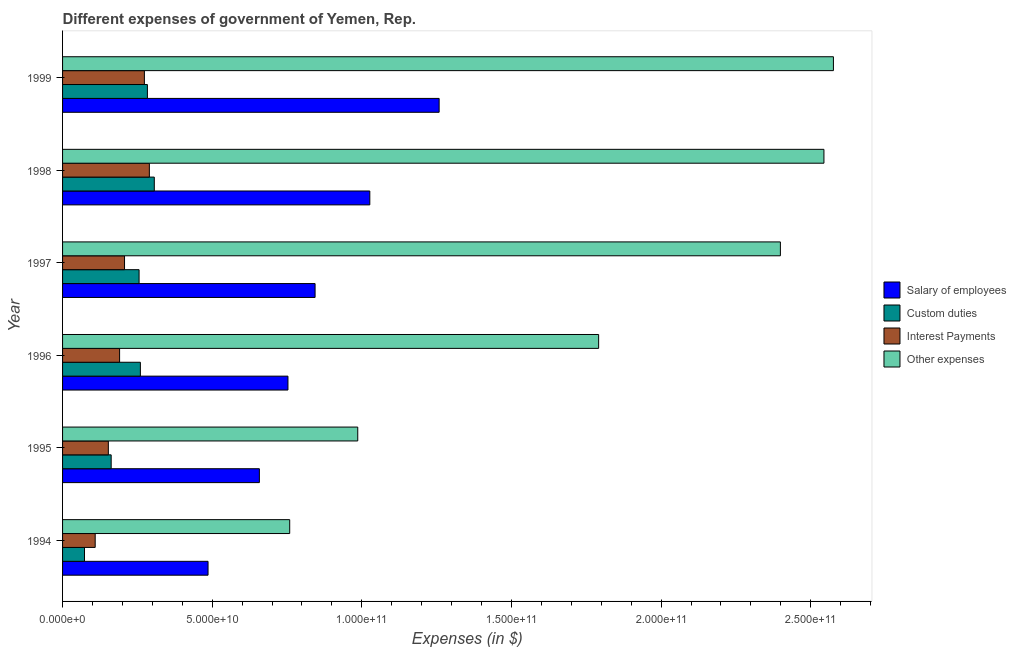How many different coloured bars are there?
Your answer should be compact. 4. How many bars are there on the 4th tick from the bottom?
Provide a succinct answer. 4. In how many cases, is the number of bars for a given year not equal to the number of legend labels?
Provide a succinct answer. 0. What is the amount spent on salary of employees in 1998?
Offer a terse response. 1.03e+11. Across all years, what is the maximum amount spent on custom duties?
Give a very brief answer. 3.07e+1. Across all years, what is the minimum amount spent on other expenses?
Provide a succinct answer. 7.59e+1. In which year was the amount spent on other expenses maximum?
Offer a very short reply. 1999. What is the total amount spent on interest payments in the graph?
Give a very brief answer. 1.22e+11. What is the difference between the amount spent on custom duties in 1995 and that in 1996?
Offer a very short reply. -9.76e+09. What is the difference between the amount spent on other expenses in 1997 and the amount spent on custom duties in 1996?
Provide a short and direct response. 2.14e+11. What is the average amount spent on other expenses per year?
Provide a succinct answer. 1.84e+11. In the year 1996, what is the difference between the amount spent on salary of employees and amount spent on other expenses?
Ensure brevity in your answer.  -1.04e+11. What is the ratio of the amount spent on other expenses in 1994 to that in 1999?
Make the answer very short. 0.29. Is the amount spent on interest payments in 1995 less than that in 1997?
Make the answer very short. Yes. Is the difference between the amount spent on salary of employees in 1996 and 1998 greater than the difference between the amount spent on interest payments in 1996 and 1998?
Offer a terse response. No. What is the difference between the highest and the second highest amount spent on custom duties?
Keep it short and to the point. 2.30e+09. What is the difference between the highest and the lowest amount spent on interest payments?
Keep it short and to the point. 1.81e+1. In how many years, is the amount spent on custom duties greater than the average amount spent on custom duties taken over all years?
Offer a terse response. 4. Is it the case that in every year, the sum of the amount spent on interest payments and amount spent on custom duties is greater than the sum of amount spent on other expenses and amount spent on salary of employees?
Ensure brevity in your answer.  No. What does the 4th bar from the top in 1999 represents?
Your answer should be compact. Salary of employees. What does the 2nd bar from the bottom in 1994 represents?
Offer a very short reply. Custom duties. Are all the bars in the graph horizontal?
Your answer should be very brief. Yes. How many years are there in the graph?
Keep it short and to the point. 6. Are the values on the major ticks of X-axis written in scientific E-notation?
Offer a very short reply. Yes. Does the graph contain any zero values?
Offer a terse response. No. Where does the legend appear in the graph?
Your answer should be compact. Center right. How many legend labels are there?
Provide a succinct answer. 4. What is the title of the graph?
Your answer should be compact. Different expenses of government of Yemen, Rep. Does "Debt policy" appear as one of the legend labels in the graph?
Your response must be concise. No. What is the label or title of the X-axis?
Provide a short and direct response. Expenses (in $). What is the label or title of the Y-axis?
Your response must be concise. Year. What is the Expenses (in $) of Salary of employees in 1994?
Your answer should be compact. 4.86e+1. What is the Expenses (in $) in Custom duties in 1994?
Ensure brevity in your answer.  7.33e+09. What is the Expenses (in $) in Interest Payments in 1994?
Keep it short and to the point. 1.09e+1. What is the Expenses (in $) of Other expenses in 1994?
Keep it short and to the point. 7.59e+1. What is the Expenses (in $) in Salary of employees in 1995?
Make the answer very short. 6.58e+1. What is the Expenses (in $) of Custom duties in 1995?
Give a very brief answer. 1.62e+1. What is the Expenses (in $) in Interest Payments in 1995?
Your response must be concise. 1.53e+1. What is the Expenses (in $) in Other expenses in 1995?
Ensure brevity in your answer.  9.86e+1. What is the Expenses (in $) in Salary of employees in 1996?
Provide a short and direct response. 7.53e+1. What is the Expenses (in $) of Custom duties in 1996?
Provide a short and direct response. 2.60e+1. What is the Expenses (in $) of Interest Payments in 1996?
Offer a very short reply. 1.91e+1. What is the Expenses (in $) of Other expenses in 1996?
Your answer should be very brief. 1.79e+11. What is the Expenses (in $) in Salary of employees in 1997?
Your answer should be very brief. 8.44e+1. What is the Expenses (in $) in Custom duties in 1997?
Ensure brevity in your answer.  2.56e+1. What is the Expenses (in $) of Interest Payments in 1997?
Your response must be concise. 2.07e+1. What is the Expenses (in $) of Other expenses in 1997?
Offer a terse response. 2.40e+11. What is the Expenses (in $) in Salary of employees in 1998?
Your answer should be compact. 1.03e+11. What is the Expenses (in $) of Custom duties in 1998?
Offer a very short reply. 3.07e+1. What is the Expenses (in $) in Interest Payments in 1998?
Provide a succinct answer. 2.90e+1. What is the Expenses (in $) of Other expenses in 1998?
Provide a short and direct response. 2.54e+11. What is the Expenses (in $) in Salary of employees in 1999?
Offer a very short reply. 1.26e+11. What is the Expenses (in $) in Custom duties in 1999?
Keep it short and to the point. 2.83e+1. What is the Expenses (in $) of Interest Payments in 1999?
Your answer should be compact. 2.73e+1. What is the Expenses (in $) in Other expenses in 1999?
Give a very brief answer. 2.58e+11. Across all years, what is the maximum Expenses (in $) in Salary of employees?
Provide a short and direct response. 1.26e+11. Across all years, what is the maximum Expenses (in $) of Custom duties?
Keep it short and to the point. 3.07e+1. Across all years, what is the maximum Expenses (in $) of Interest Payments?
Offer a terse response. 2.90e+1. Across all years, what is the maximum Expenses (in $) of Other expenses?
Make the answer very short. 2.58e+11. Across all years, what is the minimum Expenses (in $) of Salary of employees?
Keep it short and to the point. 4.86e+1. Across all years, what is the minimum Expenses (in $) of Custom duties?
Your answer should be very brief. 7.33e+09. Across all years, what is the minimum Expenses (in $) of Interest Payments?
Your answer should be compact. 1.09e+1. Across all years, what is the minimum Expenses (in $) of Other expenses?
Give a very brief answer. 7.59e+1. What is the total Expenses (in $) in Salary of employees in the graph?
Ensure brevity in your answer.  5.03e+11. What is the total Expenses (in $) in Custom duties in the graph?
Provide a short and direct response. 1.34e+11. What is the total Expenses (in $) in Interest Payments in the graph?
Offer a terse response. 1.22e+11. What is the total Expenses (in $) in Other expenses in the graph?
Your answer should be compact. 1.11e+12. What is the difference between the Expenses (in $) in Salary of employees in 1994 and that in 1995?
Keep it short and to the point. -1.72e+1. What is the difference between the Expenses (in $) in Custom duties in 1994 and that in 1995?
Make the answer very short. -8.91e+09. What is the difference between the Expenses (in $) in Interest Payments in 1994 and that in 1995?
Make the answer very short. -4.40e+09. What is the difference between the Expenses (in $) in Other expenses in 1994 and that in 1995?
Your answer should be very brief. -2.27e+1. What is the difference between the Expenses (in $) in Salary of employees in 1994 and that in 1996?
Provide a short and direct response. -2.67e+1. What is the difference between the Expenses (in $) in Custom duties in 1994 and that in 1996?
Keep it short and to the point. -1.87e+1. What is the difference between the Expenses (in $) in Interest Payments in 1994 and that in 1996?
Offer a very short reply. -8.15e+09. What is the difference between the Expenses (in $) of Other expenses in 1994 and that in 1996?
Offer a terse response. -1.03e+11. What is the difference between the Expenses (in $) of Salary of employees in 1994 and that in 1997?
Provide a short and direct response. -3.58e+1. What is the difference between the Expenses (in $) of Custom duties in 1994 and that in 1997?
Ensure brevity in your answer.  -1.82e+1. What is the difference between the Expenses (in $) of Interest Payments in 1994 and that in 1997?
Keep it short and to the point. -9.80e+09. What is the difference between the Expenses (in $) in Other expenses in 1994 and that in 1997?
Your answer should be very brief. -1.64e+11. What is the difference between the Expenses (in $) of Salary of employees in 1994 and that in 1998?
Offer a very short reply. -5.41e+1. What is the difference between the Expenses (in $) in Custom duties in 1994 and that in 1998?
Offer a very short reply. -2.33e+1. What is the difference between the Expenses (in $) of Interest Payments in 1994 and that in 1998?
Offer a terse response. -1.81e+1. What is the difference between the Expenses (in $) in Other expenses in 1994 and that in 1998?
Provide a succinct answer. -1.79e+11. What is the difference between the Expenses (in $) of Salary of employees in 1994 and that in 1999?
Your answer should be compact. -7.72e+1. What is the difference between the Expenses (in $) in Custom duties in 1994 and that in 1999?
Offer a very short reply. -2.10e+1. What is the difference between the Expenses (in $) in Interest Payments in 1994 and that in 1999?
Ensure brevity in your answer.  -1.64e+1. What is the difference between the Expenses (in $) of Other expenses in 1994 and that in 1999?
Your answer should be very brief. -1.82e+11. What is the difference between the Expenses (in $) in Salary of employees in 1995 and that in 1996?
Ensure brevity in your answer.  -9.55e+09. What is the difference between the Expenses (in $) in Custom duties in 1995 and that in 1996?
Provide a succinct answer. -9.76e+09. What is the difference between the Expenses (in $) in Interest Payments in 1995 and that in 1996?
Your answer should be very brief. -3.76e+09. What is the difference between the Expenses (in $) of Other expenses in 1995 and that in 1996?
Ensure brevity in your answer.  -8.05e+1. What is the difference between the Expenses (in $) in Salary of employees in 1995 and that in 1997?
Offer a very short reply. -1.86e+1. What is the difference between the Expenses (in $) in Custom duties in 1995 and that in 1997?
Provide a succinct answer. -9.32e+09. What is the difference between the Expenses (in $) in Interest Payments in 1995 and that in 1997?
Ensure brevity in your answer.  -5.41e+09. What is the difference between the Expenses (in $) of Other expenses in 1995 and that in 1997?
Provide a succinct answer. -1.41e+11. What is the difference between the Expenses (in $) in Salary of employees in 1995 and that in 1998?
Make the answer very short. -3.69e+1. What is the difference between the Expenses (in $) in Custom duties in 1995 and that in 1998?
Your response must be concise. -1.44e+1. What is the difference between the Expenses (in $) in Interest Payments in 1995 and that in 1998?
Provide a succinct answer. -1.37e+1. What is the difference between the Expenses (in $) of Other expenses in 1995 and that in 1998?
Your answer should be compact. -1.56e+11. What is the difference between the Expenses (in $) of Salary of employees in 1995 and that in 1999?
Your answer should be very brief. -6.01e+1. What is the difference between the Expenses (in $) in Custom duties in 1995 and that in 1999?
Keep it short and to the point. -1.21e+1. What is the difference between the Expenses (in $) of Interest Payments in 1995 and that in 1999?
Offer a very short reply. -1.20e+1. What is the difference between the Expenses (in $) of Other expenses in 1995 and that in 1999?
Provide a short and direct response. -1.59e+11. What is the difference between the Expenses (in $) of Salary of employees in 1996 and that in 1997?
Provide a short and direct response. -9.07e+09. What is the difference between the Expenses (in $) in Custom duties in 1996 and that in 1997?
Ensure brevity in your answer.  4.32e+08. What is the difference between the Expenses (in $) of Interest Payments in 1996 and that in 1997?
Give a very brief answer. -1.65e+09. What is the difference between the Expenses (in $) in Other expenses in 1996 and that in 1997?
Your response must be concise. -6.07e+1. What is the difference between the Expenses (in $) in Salary of employees in 1996 and that in 1998?
Your response must be concise. -2.74e+1. What is the difference between the Expenses (in $) in Custom duties in 1996 and that in 1998?
Make the answer very short. -4.66e+09. What is the difference between the Expenses (in $) in Interest Payments in 1996 and that in 1998?
Your response must be concise. -9.95e+09. What is the difference between the Expenses (in $) in Other expenses in 1996 and that in 1998?
Your answer should be compact. -7.53e+1. What is the difference between the Expenses (in $) of Salary of employees in 1996 and that in 1999?
Provide a short and direct response. -5.05e+1. What is the difference between the Expenses (in $) of Custom duties in 1996 and that in 1999?
Your answer should be very brief. -2.35e+09. What is the difference between the Expenses (in $) in Interest Payments in 1996 and that in 1999?
Your answer should be very brief. -8.29e+09. What is the difference between the Expenses (in $) of Other expenses in 1996 and that in 1999?
Give a very brief answer. -7.85e+1. What is the difference between the Expenses (in $) in Salary of employees in 1997 and that in 1998?
Your answer should be compact. -1.83e+1. What is the difference between the Expenses (in $) of Custom duties in 1997 and that in 1998?
Offer a terse response. -5.09e+09. What is the difference between the Expenses (in $) of Interest Payments in 1997 and that in 1998?
Keep it short and to the point. -8.29e+09. What is the difference between the Expenses (in $) of Other expenses in 1997 and that in 1998?
Your answer should be compact. -1.45e+1. What is the difference between the Expenses (in $) of Salary of employees in 1997 and that in 1999?
Your response must be concise. -4.15e+1. What is the difference between the Expenses (in $) of Custom duties in 1997 and that in 1999?
Keep it short and to the point. -2.78e+09. What is the difference between the Expenses (in $) in Interest Payments in 1997 and that in 1999?
Provide a succinct answer. -6.63e+09. What is the difference between the Expenses (in $) in Other expenses in 1997 and that in 1999?
Offer a very short reply. -1.77e+1. What is the difference between the Expenses (in $) of Salary of employees in 1998 and that in 1999?
Your answer should be very brief. -2.32e+1. What is the difference between the Expenses (in $) in Custom duties in 1998 and that in 1999?
Offer a terse response. 2.30e+09. What is the difference between the Expenses (in $) of Interest Payments in 1998 and that in 1999?
Keep it short and to the point. 1.66e+09. What is the difference between the Expenses (in $) in Other expenses in 1998 and that in 1999?
Ensure brevity in your answer.  -3.17e+09. What is the difference between the Expenses (in $) in Salary of employees in 1994 and the Expenses (in $) in Custom duties in 1995?
Provide a succinct answer. 3.24e+1. What is the difference between the Expenses (in $) in Salary of employees in 1994 and the Expenses (in $) in Interest Payments in 1995?
Offer a terse response. 3.33e+1. What is the difference between the Expenses (in $) in Salary of employees in 1994 and the Expenses (in $) in Other expenses in 1995?
Make the answer very short. -5.00e+1. What is the difference between the Expenses (in $) of Custom duties in 1994 and the Expenses (in $) of Interest Payments in 1995?
Offer a very short reply. -7.97e+09. What is the difference between the Expenses (in $) in Custom duties in 1994 and the Expenses (in $) in Other expenses in 1995?
Your answer should be very brief. -9.13e+1. What is the difference between the Expenses (in $) in Interest Payments in 1994 and the Expenses (in $) in Other expenses in 1995?
Provide a succinct answer. -8.77e+1. What is the difference between the Expenses (in $) in Salary of employees in 1994 and the Expenses (in $) in Custom duties in 1996?
Your response must be concise. 2.26e+1. What is the difference between the Expenses (in $) in Salary of employees in 1994 and the Expenses (in $) in Interest Payments in 1996?
Keep it short and to the point. 2.96e+1. What is the difference between the Expenses (in $) in Salary of employees in 1994 and the Expenses (in $) in Other expenses in 1996?
Provide a succinct answer. -1.31e+11. What is the difference between the Expenses (in $) in Custom duties in 1994 and the Expenses (in $) in Interest Payments in 1996?
Ensure brevity in your answer.  -1.17e+1. What is the difference between the Expenses (in $) of Custom duties in 1994 and the Expenses (in $) of Other expenses in 1996?
Your answer should be very brief. -1.72e+11. What is the difference between the Expenses (in $) in Interest Payments in 1994 and the Expenses (in $) in Other expenses in 1996?
Offer a very short reply. -1.68e+11. What is the difference between the Expenses (in $) of Salary of employees in 1994 and the Expenses (in $) of Custom duties in 1997?
Your answer should be compact. 2.30e+1. What is the difference between the Expenses (in $) in Salary of employees in 1994 and the Expenses (in $) in Interest Payments in 1997?
Keep it short and to the point. 2.79e+1. What is the difference between the Expenses (in $) in Salary of employees in 1994 and the Expenses (in $) in Other expenses in 1997?
Offer a very short reply. -1.91e+11. What is the difference between the Expenses (in $) of Custom duties in 1994 and the Expenses (in $) of Interest Payments in 1997?
Ensure brevity in your answer.  -1.34e+1. What is the difference between the Expenses (in $) in Custom duties in 1994 and the Expenses (in $) in Other expenses in 1997?
Provide a succinct answer. -2.33e+11. What is the difference between the Expenses (in $) of Interest Payments in 1994 and the Expenses (in $) of Other expenses in 1997?
Your response must be concise. -2.29e+11. What is the difference between the Expenses (in $) of Salary of employees in 1994 and the Expenses (in $) of Custom duties in 1998?
Your response must be concise. 1.80e+1. What is the difference between the Expenses (in $) of Salary of employees in 1994 and the Expenses (in $) of Interest Payments in 1998?
Offer a very short reply. 1.96e+1. What is the difference between the Expenses (in $) in Salary of employees in 1994 and the Expenses (in $) in Other expenses in 1998?
Provide a short and direct response. -2.06e+11. What is the difference between the Expenses (in $) of Custom duties in 1994 and the Expenses (in $) of Interest Payments in 1998?
Ensure brevity in your answer.  -2.17e+1. What is the difference between the Expenses (in $) in Custom duties in 1994 and the Expenses (in $) in Other expenses in 1998?
Provide a short and direct response. -2.47e+11. What is the difference between the Expenses (in $) in Interest Payments in 1994 and the Expenses (in $) in Other expenses in 1998?
Your response must be concise. -2.44e+11. What is the difference between the Expenses (in $) in Salary of employees in 1994 and the Expenses (in $) in Custom duties in 1999?
Your answer should be very brief. 2.03e+1. What is the difference between the Expenses (in $) of Salary of employees in 1994 and the Expenses (in $) of Interest Payments in 1999?
Offer a terse response. 2.13e+1. What is the difference between the Expenses (in $) in Salary of employees in 1994 and the Expenses (in $) in Other expenses in 1999?
Offer a very short reply. -2.09e+11. What is the difference between the Expenses (in $) of Custom duties in 1994 and the Expenses (in $) of Interest Payments in 1999?
Offer a terse response. -2.00e+1. What is the difference between the Expenses (in $) of Custom duties in 1994 and the Expenses (in $) of Other expenses in 1999?
Your answer should be very brief. -2.50e+11. What is the difference between the Expenses (in $) in Interest Payments in 1994 and the Expenses (in $) in Other expenses in 1999?
Offer a very short reply. -2.47e+11. What is the difference between the Expenses (in $) of Salary of employees in 1995 and the Expenses (in $) of Custom duties in 1996?
Make the answer very short. 3.98e+1. What is the difference between the Expenses (in $) of Salary of employees in 1995 and the Expenses (in $) of Interest Payments in 1996?
Provide a succinct answer. 4.67e+1. What is the difference between the Expenses (in $) of Salary of employees in 1995 and the Expenses (in $) of Other expenses in 1996?
Your response must be concise. -1.13e+11. What is the difference between the Expenses (in $) of Custom duties in 1995 and the Expenses (in $) of Interest Payments in 1996?
Ensure brevity in your answer.  -2.81e+09. What is the difference between the Expenses (in $) of Custom duties in 1995 and the Expenses (in $) of Other expenses in 1996?
Make the answer very short. -1.63e+11. What is the difference between the Expenses (in $) in Interest Payments in 1995 and the Expenses (in $) in Other expenses in 1996?
Keep it short and to the point. -1.64e+11. What is the difference between the Expenses (in $) in Salary of employees in 1995 and the Expenses (in $) in Custom duties in 1997?
Make the answer very short. 4.02e+1. What is the difference between the Expenses (in $) of Salary of employees in 1995 and the Expenses (in $) of Interest Payments in 1997?
Your answer should be compact. 4.51e+1. What is the difference between the Expenses (in $) of Salary of employees in 1995 and the Expenses (in $) of Other expenses in 1997?
Your answer should be very brief. -1.74e+11. What is the difference between the Expenses (in $) in Custom duties in 1995 and the Expenses (in $) in Interest Payments in 1997?
Make the answer very short. -4.47e+09. What is the difference between the Expenses (in $) in Custom duties in 1995 and the Expenses (in $) in Other expenses in 1997?
Offer a very short reply. -2.24e+11. What is the difference between the Expenses (in $) of Interest Payments in 1995 and the Expenses (in $) of Other expenses in 1997?
Make the answer very short. -2.25e+11. What is the difference between the Expenses (in $) in Salary of employees in 1995 and the Expenses (in $) in Custom duties in 1998?
Provide a short and direct response. 3.51e+1. What is the difference between the Expenses (in $) of Salary of employees in 1995 and the Expenses (in $) of Interest Payments in 1998?
Provide a succinct answer. 3.68e+1. What is the difference between the Expenses (in $) in Salary of employees in 1995 and the Expenses (in $) in Other expenses in 1998?
Give a very brief answer. -1.89e+11. What is the difference between the Expenses (in $) of Custom duties in 1995 and the Expenses (in $) of Interest Payments in 1998?
Your answer should be very brief. -1.28e+1. What is the difference between the Expenses (in $) of Custom duties in 1995 and the Expenses (in $) of Other expenses in 1998?
Offer a very short reply. -2.38e+11. What is the difference between the Expenses (in $) of Interest Payments in 1995 and the Expenses (in $) of Other expenses in 1998?
Keep it short and to the point. -2.39e+11. What is the difference between the Expenses (in $) of Salary of employees in 1995 and the Expenses (in $) of Custom duties in 1999?
Your answer should be very brief. 3.74e+1. What is the difference between the Expenses (in $) of Salary of employees in 1995 and the Expenses (in $) of Interest Payments in 1999?
Your answer should be compact. 3.84e+1. What is the difference between the Expenses (in $) of Salary of employees in 1995 and the Expenses (in $) of Other expenses in 1999?
Your response must be concise. -1.92e+11. What is the difference between the Expenses (in $) in Custom duties in 1995 and the Expenses (in $) in Interest Payments in 1999?
Offer a very short reply. -1.11e+1. What is the difference between the Expenses (in $) of Custom duties in 1995 and the Expenses (in $) of Other expenses in 1999?
Offer a terse response. -2.41e+11. What is the difference between the Expenses (in $) of Interest Payments in 1995 and the Expenses (in $) of Other expenses in 1999?
Ensure brevity in your answer.  -2.42e+11. What is the difference between the Expenses (in $) in Salary of employees in 1996 and the Expenses (in $) in Custom duties in 1997?
Your answer should be compact. 4.97e+1. What is the difference between the Expenses (in $) of Salary of employees in 1996 and the Expenses (in $) of Interest Payments in 1997?
Offer a very short reply. 5.46e+1. What is the difference between the Expenses (in $) of Salary of employees in 1996 and the Expenses (in $) of Other expenses in 1997?
Your answer should be very brief. -1.65e+11. What is the difference between the Expenses (in $) in Custom duties in 1996 and the Expenses (in $) in Interest Payments in 1997?
Provide a succinct answer. 5.29e+09. What is the difference between the Expenses (in $) in Custom duties in 1996 and the Expenses (in $) in Other expenses in 1997?
Your answer should be compact. -2.14e+11. What is the difference between the Expenses (in $) of Interest Payments in 1996 and the Expenses (in $) of Other expenses in 1997?
Your response must be concise. -2.21e+11. What is the difference between the Expenses (in $) of Salary of employees in 1996 and the Expenses (in $) of Custom duties in 1998?
Give a very brief answer. 4.47e+1. What is the difference between the Expenses (in $) of Salary of employees in 1996 and the Expenses (in $) of Interest Payments in 1998?
Offer a very short reply. 4.63e+1. What is the difference between the Expenses (in $) of Salary of employees in 1996 and the Expenses (in $) of Other expenses in 1998?
Provide a succinct answer. -1.79e+11. What is the difference between the Expenses (in $) of Custom duties in 1996 and the Expenses (in $) of Interest Payments in 1998?
Provide a short and direct response. -3.00e+09. What is the difference between the Expenses (in $) of Custom duties in 1996 and the Expenses (in $) of Other expenses in 1998?
Provide a succinct answer. -2.28e+11. What is the difference between the Expenses (in $) in Interest Payments in 1996 and the Expenses (in $) in Other expenses in 1998?
Make the answer very short. -2.35e+11. What is the difference between the Expenses (in $) in Salary of employees in 1996 and the Expenses (in $) in Custom duties in 1999?
Make the answer very short. 4.70e+1. What is the difference between the Expenses (in $) in Salary of employees in 1996 and the Expenses (in $) in Interest Payments in 1999?
Your response must be concise. 4.80e+1. What is the difference between the Expenses (in $) of Salary of employees in 1996 and the Expenses (in $) of Other expenses in 1999?
Offer a very short reply. -1.82e+11. What is the difference between the Expenses (in $) of Custom duties in 1996 and the Expenses (in $) of Interest Payments in 1999?
Your answer should be very brief. -1.34e+09. What is the difference between the Expenses (in $) of Custom duties in 1996 and the Expenses (in $) of Other expenses in 1999?
Keep it short and to the point. -2.32e+11. What is the difference between the Expenses (in $) of Interest Payments in 1996 and the Expenses (in $) of Other expenses in 1999?
Offer a terse response. -2.39e+11. What is the difference between the Expenses (in $) of Salary of employees in 1997 and the Expenses (in $) of Custom duties in 1998?
Provide a short and direct response. 5.37e+1. What is the difference between the Expenses (in $) of Salary of employees in 1997 and the Expenses (in $) of Interest Payments in 1998?
Your answer should be very brief. 5.54e+1. What is the difference between the Expenses (in $) of Salary of employees in 1997 and the Expenses (in $) of Other expenses in 1998?
Provide a succinct answer. -1.70e+11. What is the difference between the Expenses (in $) of Custom duties in 1997 and the Expenses (in $) of Interest Payments in 1998?
Provide a short and direct response. -3.44e+09. What is the difference between the Expenses (in $) of Custom duties in 1997 and the Expenses (in $) of Other expenses in 1998?
Ensure brevity in your answer.  -2.29e+11. What is the difference between the Expenses (in $) in Interest Payments in 1997 and the Expenses (in $) in Other expenses in 1998?
Make the answer very short. -2.34e+11. What is the difference between the Expenses (in $) of Salary of employees in 1997 and the Expenses (in $) of Custom duties in 1999?
Make the answer very short. 5.60e+1. What is the difference between the Expenses (in $) in Salary of employees in 1997 and the Expenses (in $) in Interest Payments in 1999?
Your answer should be very brief. 5.70e+1. What is the difference between the Expenses (in $) in Salary of employees in 1997 and the Expenses (in $) in Other expenses in 1999?
Provide a short and direct response. -1.73e+11. What is the difference between the Expenses (in $) of Custom duties in 1997 and the Expenses (in $) of Interest Payments in 1999?
Provide a succinct answer. -1.77e+09. What is the difference between the Expenses (in $) in Custom duties in 1997 and the Expenses (in $) in Other expenses in 1999?
Keep it short and to the point. -2.32e+11. What is the difference between the Expenses (in $) in Interest Payments in 1997 and the Expenses (in $) in Other expenses in 1999?
Your answer should be compact. -2.37e+11. What is the difference between the Expenses (in $) in Salary of employees in 1998 and the Expenses (in $) in Custom duties in 1999?
Your answer should be very brief. 7.43e+1. What is the difference between the Expenses (in $) of Salary of employees in 1998 and the Expenses (in $) of Interest Payments in 1999?
Your response must be concise. 7.53e+1. What is the difference between the Expenses (in $) of Salary of employees in 1998 and the Expenses (in $) of Other expenses in 1999?
Your answer should be very brief. -1.55e+11. What is the difference between the Expenses (in $) of Custom duties in 1998 and the Expenses (in $) of Interest Payments in 1999?
Make the answer very short. 3.31e+09. What is the difference between the Expenses (in $) in Custom duties in 1998 and the Expenses (in $) in Other expenses in 1999?
Keep it short and to the point. -2.27e+11. What is the difference between the Expenses (in $) in Interest Payments in 1998 and the Expenses (in $) in Other expenses in 1999?
Your response must be concise. -2.29e+11. What is the average Expenses (in $) in Salary of employees per year?
Give a very brief answer. 8.38e+1. What is the average Expenses (in $) of Custom duties per year?
Your answer should be compact. 2.24e+1. What is the average Expenses (in $) of Interest Payments per year?
Your response must be concise. 2.04e+1. What is the average Expenses (in $) of Other expenses per year?
Provide a succinct answer. 1.84e+11. In the year 1994, what is the difference between the Expenses (in $) in Salary of employees and Expenses (in $) in Custom duties?
Give a very brief answer. 4.13e+1. In the year 1994, what is the difference between the Expenses (in $) of Salary of employees and Expenses (in $) of Interest Payments?
Provide a short and direct response. 3.77e+1. In the year 1994, what is the difference between the Expenses (in $) in Salary of employees and Expenses (in $) in Other expenses?
Keep it short and to the point. -2.73e+1. In the year 1994, what is the difference between the Expenses (in $) in Custom duties and Expenses (in $) in Interest Payments?
Ensure brevity in your answer.  -3.57e+09. In the year 1994, what is the difference between the Expenses (in $) of Custom duties and Expenses (in $) of Other expenses?
Keep it short and to the point. -6.86e+1. In the year 1994, what is the difference between the Expenses (in $) of Interest Payments and Expenses (in $) of Other expenses?
Ensure brevity in your answer.  -6.50e+1. In the year 1995, what is the difference between the Expenses (in $) of Salary of employees and Expenses (in $) of Custom duties?
Give a very brief answer. 4.95e+1. In the year 1995, what is the difference between the Expenses (in $) in Salary of employees and Expenses (in $) in Interest Payments?
Your answer should be compact. 5.05e+1. In the year 1995, what is the difference between the Expenses (in $) in Salary of employees and Expenses (in $) in Other expenses?
Provide a succinct answer. -3.29e+1. In the year 1995, what is the difference between the Expenses (in $) of Custom duties and Expenses (in $) of Interest Payments?
Your response must be concise. 9.43e+08. In the year 1995, what is the difference between the Expenses (in $) of Custom duties and Expenses (in $) of Other expenses?
Your answer should be compact. -8.24e+1. In the year 1995, what is the difference between the Expenses (in $) of Interest Payments and Expenses (in $) of Other expenses?
Ensure brevity in your answer.  -8.33e+1. In the year 1996, what is the difference between the Expenses (in $) in Salary of employees and Expenses (in $) in Custom duties?
Offer a very short reply. 4.93e+1. In the year 1996, what is the difference between the Expenses (in $) in Salary of employees and Expenses (in $) in Interest Payments?
Ensure brevity in your answer.  5.63e+1. In the year 1996, what is the difference between the Expenses (in $) in Salary of employees and Expenses (in $) in Other expenses?
Offer a terse response. -1.04e+11. In the year 1996, what is the difference between the Expenses (in $) in Custom duties and Expenses (in $) in Interest Payments?
Provide a short and direct response. 6.94e+09. In the year 1996, what is the difference between the Expenses (in $) in Custom duties and Expenses (in $) in Other expenses?
Your answer should be compact. -1.53e+11. In the year 1996, what is the difference between the Expenses (in $) in Interest Payments and Expenses (in $) in Other expenses?
Offer a terse response. -1.60e+11. In the year 1997, what is the difference between the Expenses (in $) of Salary of employees and Expenses (in $) of Custom duties?
Provide a succinct answer. 5.88e+1. In the year 1997, what is the difference between the Expenses (in $) of Salary of employees and Expenses (in $) of Interest Payments?
Your answer should be very brief. 6.37e+1. In the year 1997, what is the difference between the Expenses (in $) in Salary of employees and Expenses (in $) in Other expenses?
Offer a terse response. -1.55e+11. In the year 1997, what is the difference between the Expenses (in $) in Custom duties and Expenses (in $) in Interest Payments?
Make the answer very short. 4.86e+09. In the year 1997, what is the difference between the Expenses (in $) in Custom duties and Expenses (in $) in Other expenses?
Your answer should be compact. -2.14e+11. In the year 1997, what is the difference between the Expenses (in $) in Interest Payments and Expenses (in $) in Other expenses?
Make the answer very short. -2.19e+11. In the year 1998, what is the difference between the Expenses (in $) in Salary of employees and Expenses (in $) in Custom duties?
Offer a very short reply. 7.20e+1. In the year 1998, what is the difference between the Expenses (in $) in Salary of employees and Expenses (in $) in Interest Payments?
Your answer should be very brief. 7.37e+1. In the year 1998, what is the difference between the Expenses (in $) of Salary of employees and Expenses (in $) of Other expenses?
Your answer should be compact. -1.52e+11. In the year 1998, what is the difference between the Expenses (in $) in Custom duties and Expenses (in $) in Interest Payments?
Ensure brevity in your answer.  1.65e+09. In the year 1998, what is the difference between the Expenses (in $) of Custom duties and Expenses (in $) of Other expenses?
Make the answer very short. -2.24e+11. In the year 1998, what is the difference between the Expenses (in $) of Interest Payments and Expenses (in $) of Other expenses?
Your answer should be very brief. -2.25e+11. In the year 1999, what is the difference between the Expenses (in $) of Salary of employees and Expenses (in $) of Custom duties?
Offer a terse response. 9.75e+1. In the year 1999, what is the difference between the Expenses (in $) in Salary of employees and Expenses (in $) in Interest Payments?
Your response must be concise. 9.85e+1. In the year 1999, what is the difference between the Expenses (in $) in Salary of employees and Expenses (in $) in Other expenses?
Your response must be concise. -1.32e+11. In the year 1999, what is the difference between the Expenses (in $) in Custom duties and Expenses (in $) in Interest Payments?
Make the answer very short. 1.01e+09. In the year 1999, what is the difference between the Expenses (in $) in Custom duties and Expenses (in $) in Other expenses?
Your answer should be compact. -2.29e+11. In the year 1999, what is the difference between the Expenses (in $) in Interest Payments and Expenses (in $) in Other expenses?
Offer a very short reply. -2.30e+11. What is the ratio of the Expenses (in $) of Salary of employees in 1994 to that in 1995?
Offer a very short reply. 0.74. What is the ratio of the Expenses (in $) in Custom duties in 1994 to that in 1995?
Provide a succinct answer. 0.45. What is the ratio of the Expenses (in $) of Interest Payments in 1994 to that in 1995?
Ensure brevity in your answer.  0.71. What is the ratio of the Expenses (in $) of Other expenses in 1994 to that in 1995?
Your answer should be compact. 0.77. What is the ratio of the Expenses (in $) of Salary of employees in 1994 to that in 1996?
Provide a succinct answer. 0.65. What is the ratio of the Expenses (in $) of Custom duties in 1994 to that in 1996?
Provide a short and direct response. 0.28. What is the ratio of the Expenses (in $) in Interest Payments in 1994 to that in 1996?
Offer a terse response. 0.57. What is the ratio of the Expenses (in $) of Other expenses in 1994 to that in 1996?
Keep it short and to the point. 0.42. What is the ratio of the Expenses (in $) of Salary of employees in 1994 to that in 1997?
Give a very brief answer. 0.58. What is the ratio of the Expenses (in $) of Custom duties in 1994 to that in 1997?
Provide a short and direct response. 0.29. What is the ratio of the Expenses (in $) of Interest Payments in 1994 to that in 1997?
Ensure brevity in your answer.  0.53. What is the ratio of the Expenses (in $) of Other expenses in 1994 to that in 1997?
Provide a succinct answer. 0.32. What is the ratio of the Expenses (in $) in Salary of employees in 1994 to that in 1998?
Your response must be concise. 0.47. What is the ratio of the Expenses (in $) in Custom duties in 1994 to that in 1998?
Your response must be concise. 0.24. What is the ratio of the Expenses (in $) of Interest Payments in 1994 to that in 1998?
Make the answer very short. 0.38. What is the ratio of the Expenses (in $) in Other expenses in 1994 to that in 1998?
Make the answer very short. 0.3. What is the ratio of the Expenses (in $) of Salary of employees in 1994 to that in 1999?
Provide a short and direct response. 0.39. What is the ratio of the Expenses (in $) in Custom duties in 1994 to that in 1999?
Your answer should be compact. 0.26. What is the ratio of the Expenses (in $) in Interest Payments in 1994 to that in 1999?
Your response must be concise. 0.4. What is the ratio of the Expenses (in $) in Other expenses in 1994 to that in 1999?
Give a very brief answer. 0.29. What is the ratio of the Expenses (in $) in Salary of employees in 1995 to that in 1996?
Ensure brevity in your answer.  0.87. What is the ratio of the Expenses (in $) in Custom duties in 1995 to that in 1996?
Offer a terse response. 0.62. What is the ratio of the Expenses (in $) of Interest Payments in 1995 to that in 1996?
Provide a short and direct response. 0.8. What is the ratio of the Expenses (in $) of Other expenses in 1995 to that in 1996?
Provide a short and direct response. 0.55. What is the ratio of the Expenses (in $) of Salary of employees in 1995 to that in 1997?
Provide a short and direct response. 0.78. What is the ratio of the Expenses (in $) in Custom duties in 1995 to that in 1997?
Offer a very short reply. 0.64. What is the ratio of the Expenses (in $) of Interest Payments in 1995 to that in 1997?
Provide a succinct answer. 0.74. What is the ratio of the Expenses (in $) of Other expenses in 1995 to that in 1997?
Offer a terse response. 0.41. What is the ratio of the Expenses (in $) of Salary of employees in 1995 to that in 1998?
Your answer should be very brief. 0.64. What is the ratio of the Expenses (in $) of Custom duties in 1995 to that in 1998?
Your response must be concise. 0.53. What is the ratio of the Expenses (in $) of Interest Payments in 1995 to that in 1998?
Ensure brevity in your answer.  0.53. What is the ratio of the Expenses (in $) in Other expenses in 1995 to that in 1998?
Keep it short and to the point. 0.39. What is the ratio of the Expenses (in $) of Salary of employees in 1995 to that in 1999?
Your answer should be compact. 0.52. What is the ratio of the Expenses (in $) in Custom duties in 1995 to that in 1999?
Your answer should be very brief. 0.57. What is the ratio of the Expenses (in $) of Interest Payments in 1995 to that in 1999?
Your answer should be very brief. 0.56. What is the ratio of the Expenses (in $) of Other expenses in 1995 to that in 1999?
Keep it short and to the point. 0.38. What is the ratio of the Expenses (in $) of Salary of employees in 1996 to that in 1997?
Provide a succinct answer. 0.89. What is the ratio of the Expenses (in $) in Custom duties in 1996 to that in 1997?
Provide a short and direct response. 1.02. What is the ratio of the Expenses (in $) of Interest Payments in 1996 to that in 1997?
Offer a terse response. 0.92. What is the ratio of the Expenses (in $) in Other expenses in 1996 to that in 1997?
Provide a short and direct response. 0.75. What is the ratio of the Expenses (in $) of Salary of employees in 1996 to that in 1998?
Offer a terse response. 0.73. What is the ratio of the Expenses (in $) in Custom duties in 1996 to that in 1998?
Provide a succinct answer. 0.85. What is the ratio of the Expenses (in $) of Interest Payments in 1996 to that in 1998?
Offer a very short reply. 0.66. What is the ratio of the Expenses (in $) in Other expenses in 1996 to that in 1998?
Ensure brevity in your answer.  0.7. What is the ratio of the Expenses (in $) of Salary of employees in 1996 to that in 1999?
Provide a succinct answer. 0.6. What is the ratio of the Expenses (in $) of Custom duties in 1996 to that in 1999?
Offer a very short reply. 0.92. What is the ratio of the Expenses (in $) in Interest Payments in 1996 to that in 1999?
Keep it short and to the point. 0.7. What is the ratio of the Expenses (in $) in Other expenses in 1996 to that in 1999?
Ensure brevity in your answer.  0.7. What is the ratio of the Expenses (in $) in Salary of employees in 1997 to that in 1998?
Your answer should be very brief. 0.82. What is the ratio of the Expenses (in $) in Custom duties in 1997 to that in 1998?
Your answer should be compact. 0.83. What is the ratio of the Expenses (in $) in Interest Payments in 1997 to that in 1998?
Offer a terse response. 0.71. What is the ratio of the Expenses (in $) of Other expenses in 1997 to that in 1998?
Offer a terse response. 0.94. What is the ratio of the Expenses (in $) in Salary of employees in 1997 to that in 1999?
Your answer should be very brief. 0.67. What is the ratio of the Expenses (in $) of Custom duties in 1997 to that in 1999?
Your response must be concise. 0.9. What is the ratio of the Expenses (in $) in Interest Payments in 1997 to that in 1999?
Your answer should be compact. 0.76. What is the ratio of the Expenses (in $) of Other expenses in 1997 to that in 1999?
Your response must be concise. 0.93. What is the ratio of the Expenses (in $) in Salary of employees in 1998 to that in 1999?
Your answer should be very brief. 0.82. What is the ratio of the Expenses (in $) of Custom duties in 1998 to that in 1999?
Offer a very short reply. 1.08. What is the ratio of the Expenses (in $) of Interest Payments in 1998 to that in 1999?
Your answer should be very brief. 1.06. What is the ratio of the Expenses (in $) of Other expenses in 1998 to that in 1999?
Your answer should be very brief. 0.99. What is the difference between the highest and the second highest Expenses (in $) in Salary of employees?
Your answer should be compact. 2.32e+1. What is the difference between the highest and the second highest Expenses (in $) in Custom duties?
Keep it short and to the point. 2.30e+09. What is the difference between the highest and the second highest Expenses (in $) in Interest Payments?
Offer a terse response. 1.66e+09. What is the difference between the highest and the second highest Expenses (in $) in Other expenses?
Offer a terse response. 3.17e+09. What is the difference between the highest and the lowest Expenses (in $) in Salary of employees?
Provide a succinct answer. 7.72e+1. What is the difference between the highest and the lowest Expenses (in $) of Custom duties?
Make the answer very short. 2.33e+1. What is the difference between the highest and the lowest Expenses (in $) of Interest Payments?
Ensure brevity in your answer.  1.81e+1. What is the difference between the highest and the lowest Expenses (in $) of Other expenses?
Keep it short and to the point. 1.82e+11. 